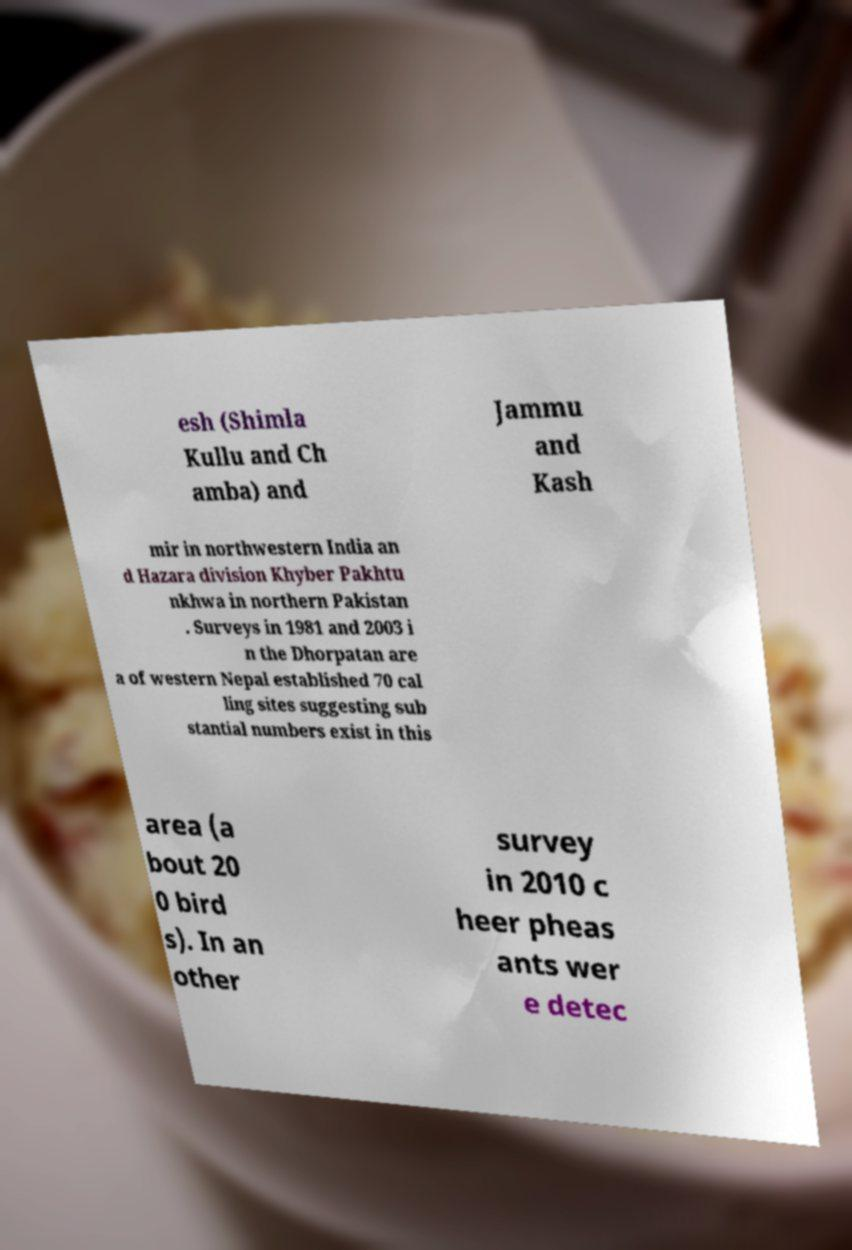Can you read and provide the text displayed in the image?This photo seems to have some interesting text. Can you extract and type it out for me? esh (Shimla Kullu and Ch amba) and Jammu and Kash mir in northwestern India an d Hazara division Khyber Pakhtu nkhwa in northern Pakistan . Surveys in 1981 and 2003 i n the Dhorpatan are a of western Nepal established 70 cal ling sites suggesting sub stantial numbers exist in this area (a bout 20 0 bird s). In an other survey in 2010 c heer pheas ants wer e detec 